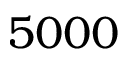Convert formula to latex. <formula><loc_0><loc_0><loc_500><loc_500>5 0 0 0</formula> 